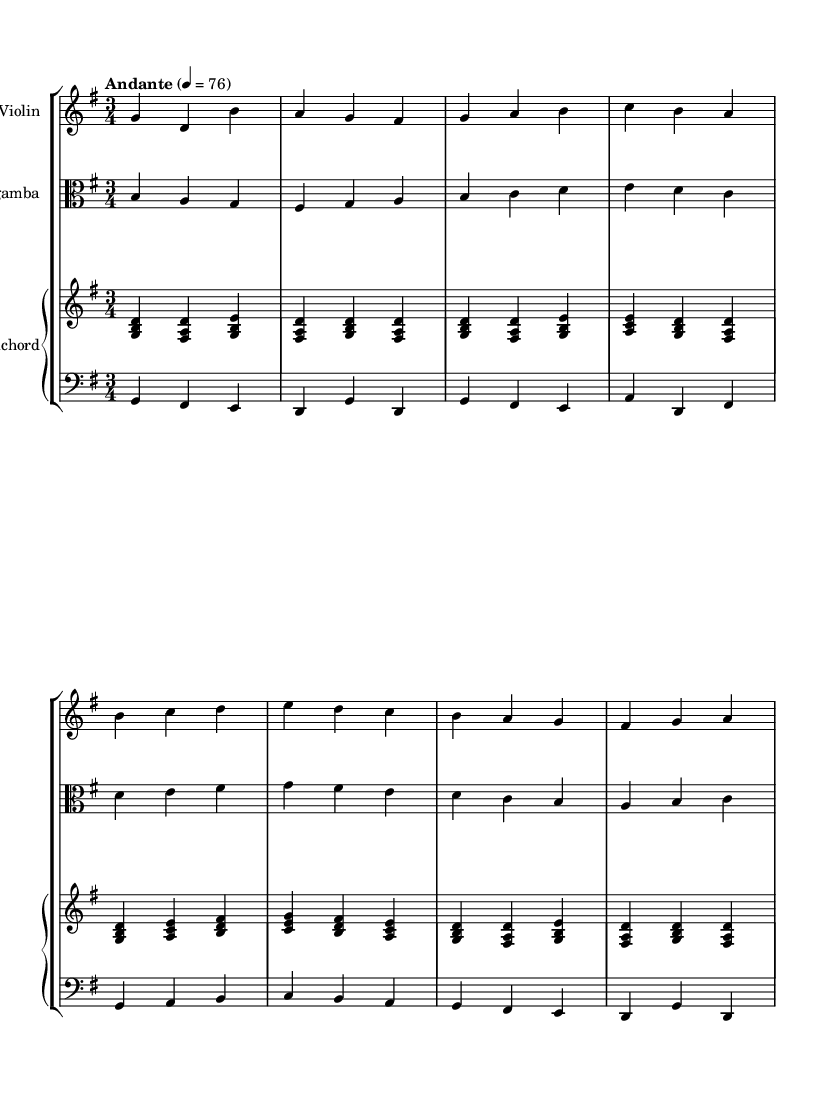What is the key signature of this music? The key signature is G major, which has one sharp (F#). This can be identified by looking at the key signature indicated at the beginning of the staff.
Answer: G major What is the time signature of the piece? The time signature is 3/4, which indicates that there are three beats in each measure and a quarter note gets one beat. This can be seen right next to the clef at the start of the score.
Answer: 3/4 What is the tempo marking for this piece? The tempo marking is "Andante," which means a moderate walking pace. This can be found indicated at the beginning of the score with the metronome marking of 76.
Answer: Andante How many instruments are featured in this piece? There are four instruments featured: violin, viola da gamba, and harpsichord (which includes upper and lower staves for the piano). This can be counted from the staff groupings at the beginning of the score.
Answer: Four What is the character of the piece based on the tempo and style? The character is calming and reflective, typical of Baroque chamber music, which often features gentle melodies and a lyrical quality. This is derived from the Andante tempo and the overall melodic structure.
Answer: Calming Which sections have a consistent melodic line? The violin and viola da gamba sections have consistent melodic lines throughout the piece, following structured phrases. This can be observed in how both instruments have clear, flowing melodies that correspond with one another.
Answer: Violin and viola da gamba 